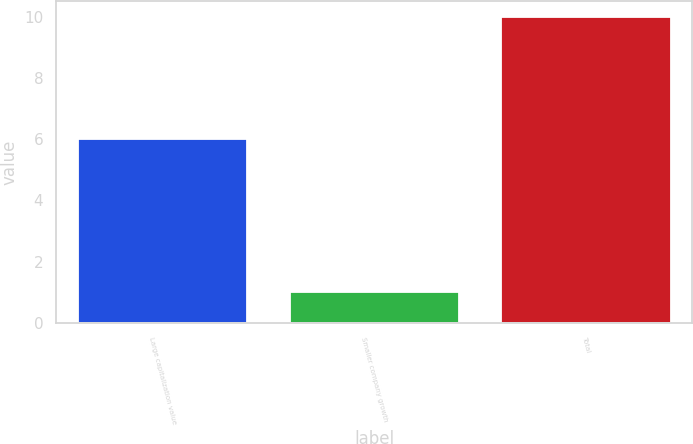Convert chart to OTSL. <chart><loc_0><loc_0><loc_500><loc_500><bar_chart><fcel>Large capitalization value<fcel>Smaller company growth<fcel>Total<nl><fcel>6<fcel>1<fcel>10<nl></chart> 